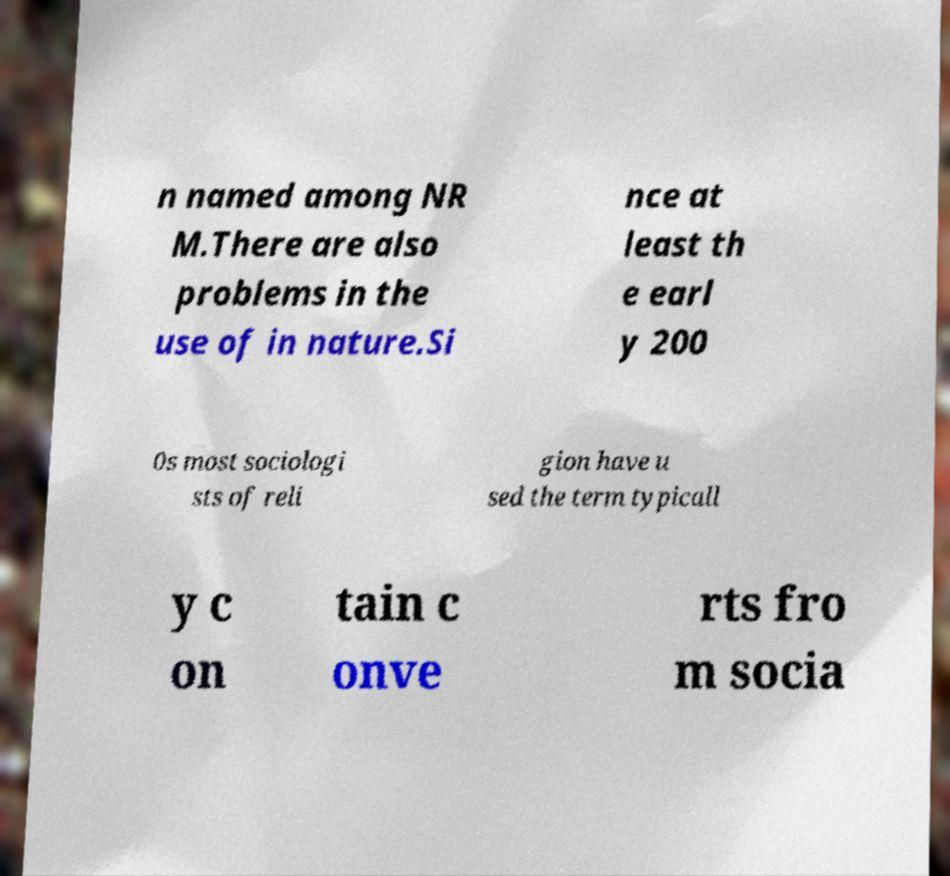What messages or text are displayed in this image? I need them in a readable, typed format. n named among NR M.There are also problems in the use of in nature.Si nce at least th e earl y 200 0s most sociologi sts of reli gion have u sed the term typicall y c on tain c onve rts fro m socia 